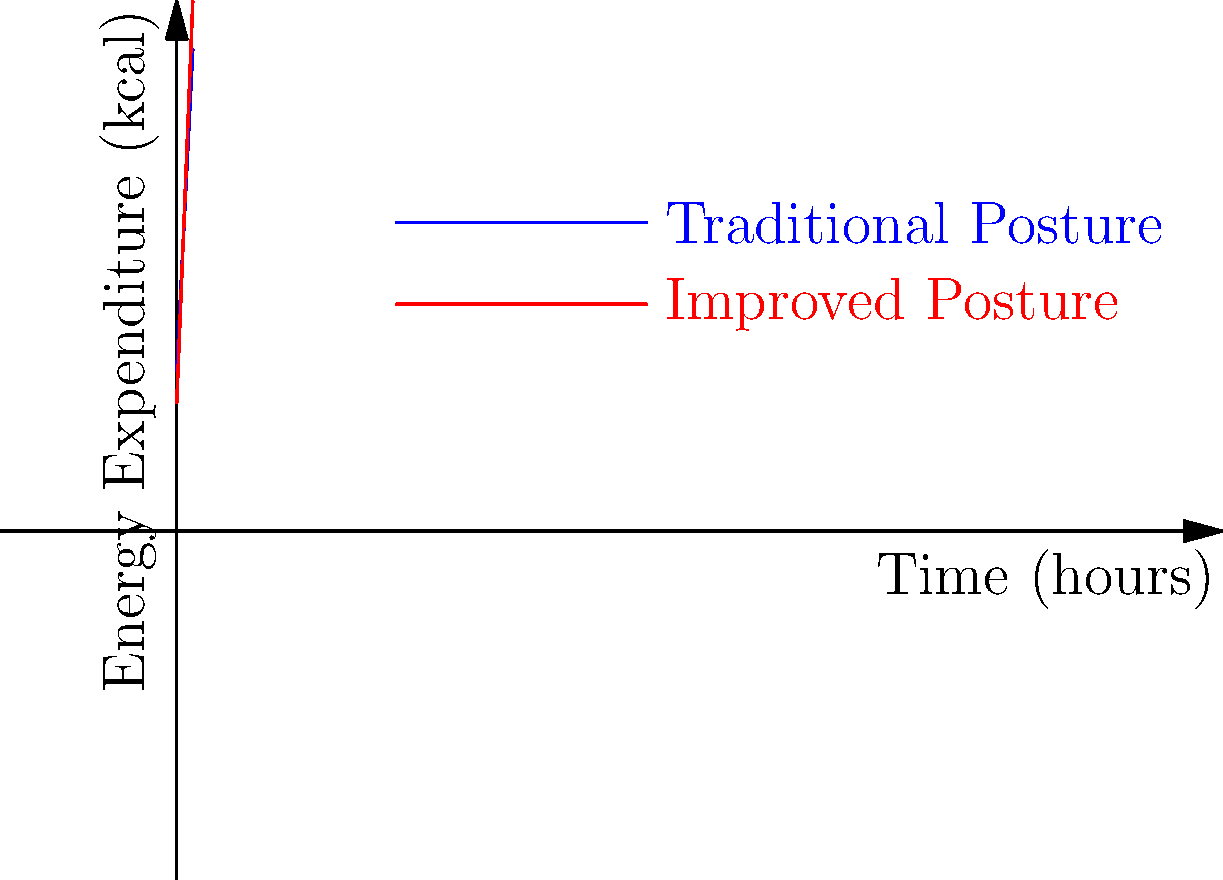Based on the graph comparing energy expenditure over time for traditional and improved Aztec farming postures, calculate the difference in total energy expended after 4 hours of work. Assume the initial energy expenditure (y-intercept) represents the basal metabolic rate. How does this relate to the biomechanical efficiency of Aztec farming techniques? To solve this problem, we need to follow these steps:

1. Identify the equations for both postures:
   Traditional Posture: $y = 50 + 20x$
   Improved Posture: $y = 40 + 25x$

2. Calculate the total energy expended for each posture after 4 hours:
   Traditional: $y = 50 + 20(4) = 50 + 80 = 130$ kcal
   Improved: $y = 40 + 25(4) = 40 + 100 = 140$ kcal

3. Calculate the difference in energy expended:
   Difference = Improved - Traditional
               = 140 - 130 = 10 kcal

4. Interpret the results:
   The improved posture actually expends 10 kcal more energy over 4 hours. However, this doesn't necessarily mean it's less efficient. The steeper slope (25 vs 20) indicates that more work is being done per unit time, which could result in higher productivity.

5. Relate to biomechanical efficiency:
   Biomechanical efficiency is about maximizing output while minimizing stress on the body. The improved posture, while using slightly more energy, may reduce strain on specific muscle groups or joints, allowing for longer work periods and potentially higher overall yield.
Answer: 10 kcal more energy expended with improved posture; indicates potentially higher work output and better long-term biomechanical efficiency. 